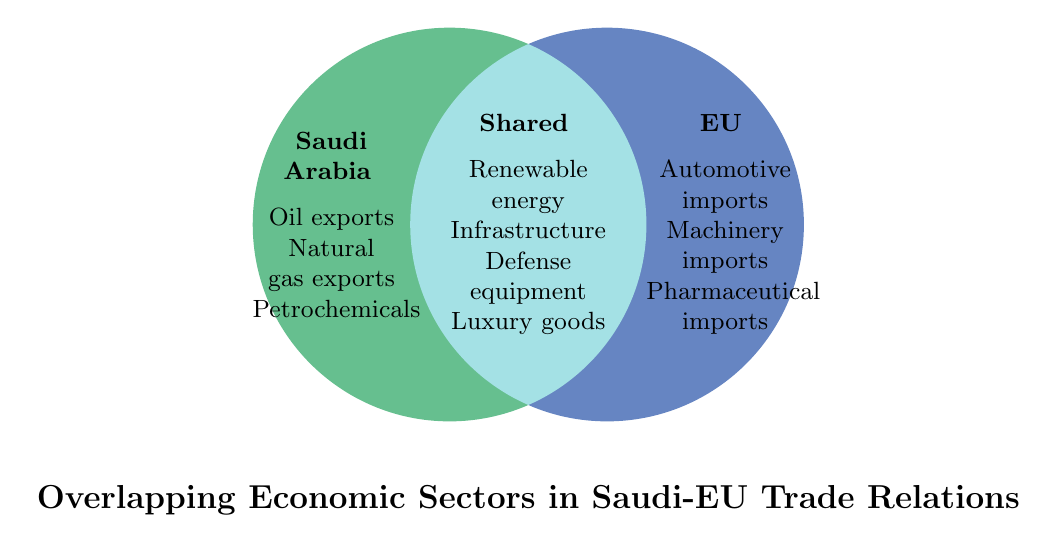What are the economic sectors exported by Saudi Arabia? The figure shows that in the Saudi Arabia circle (left side), the sectors are Oil exports, Natural gas exports, and Petrochemicals.
Answer: Oil exports, Natural gas exports, Petrochemicals What are the economic sectors imported by the EU? The figure shows that in the EU circle (right side), the sectors are Automotive imports, Machinery imports, and Pharmaceutical imports.
Answer: Automotive imports, Machinery imports, Pharmaceutical imports Which economic sectors are shared by both Saudi Arabia and the EU? The shared circle (overlapping part) lists the sectors: Renewable energy, Infrastructure, Defense equipment, and Luxury goods.
Answer: Renewable energy, Infrastructure, Defense equipment, Luxury goods How many economic sectors in total are listed for Saudi Arabia? There are three sectors listed under Saudi Arabia: Oil exports, Natural gas exports, and Petrochemicals.
Answer: 3 How many economic sectors are unique to the EU? The sectors unique to the EU include Automotive imports, Machinery imports, and Pharmaceutical imports.
Answer: 3 How many shared economic sectors are there? The shared circle has four sectors: Renewable energy, Infrastructure, Defense equipment, and Luxury goods.
Answer: 4 Which side of the Venn Diagram contains the sector for Oil exports? The left side of the Venn Diagram, which represents Saudi Arabia, contains the sector for Oil exports.
Answer: Left Compare the number of sectors unique to Saudi and the EU. Which has more? Saudi Arabia has three unique sectors, and the EU also has three unique sectors. Both have the same number of unique sectors.
Answer: Equal Are there more unique or shared economic sectors? The unique sectors for Saudi Arabia and the EU combined are six, and the shared sectors are four. Thus, there are more unique sectors.
Answer: Unique Name one example of a sector that is shared. The shared circle lists Renewable energy as one of the examples.
Answer: Renewable energy 